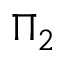Convert formula to latex. <formula><loc_0><loc_0><loc_500><loc_500>\Pi _ { 2 }</formula> 